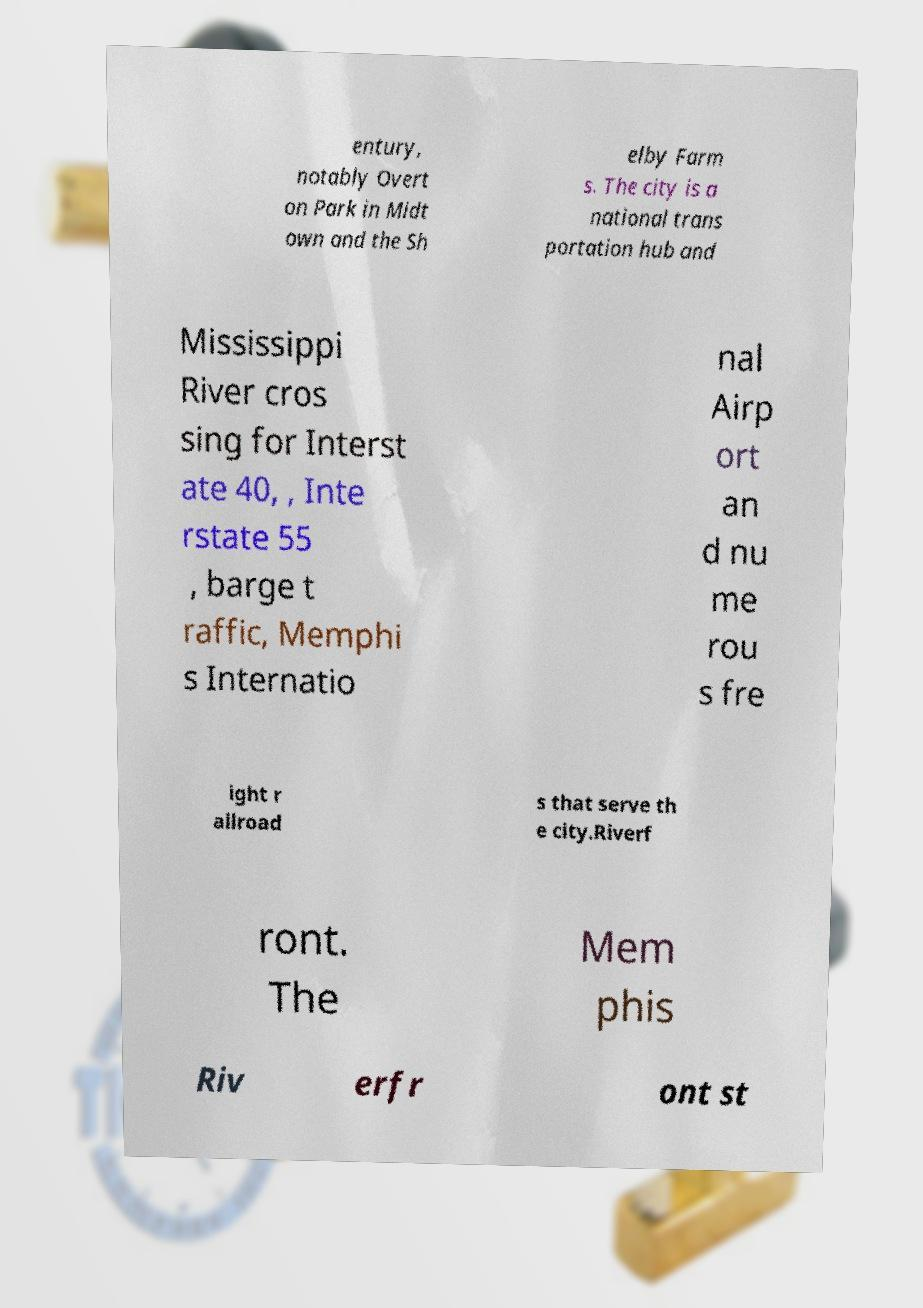Please read and relay the text visible in this image. What does it say? entury, notably Overt on Park in Midt own and the Sh elby Farm s. The city is a national trans portation hub and Mississippi River cros sing for Interst ate 40, , Inte rstate 55 , barge t raffic, Memphi s Internatio nal Airp ort an d nu me rou s fre ight r ailroad s that serve th e city.Riverf ront. The Mem phis Riv erfr ont st 